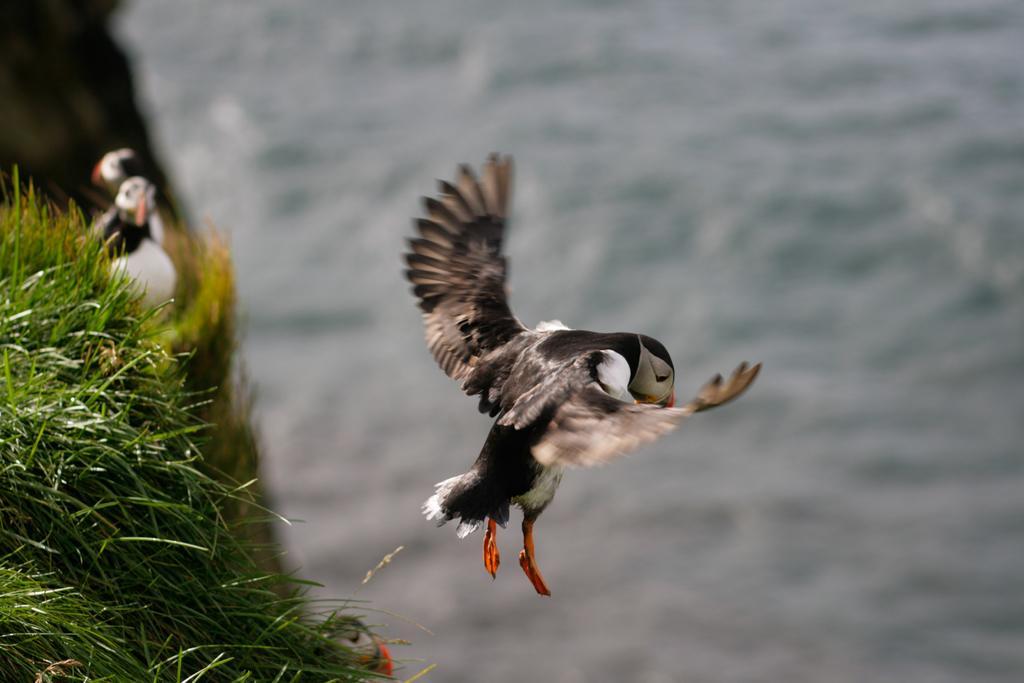Describe this image in one or two sentences. In this image we can see there is a bird flying in the air, below the bird there is a river. On the left side of the image there are other two birds on the grass. 